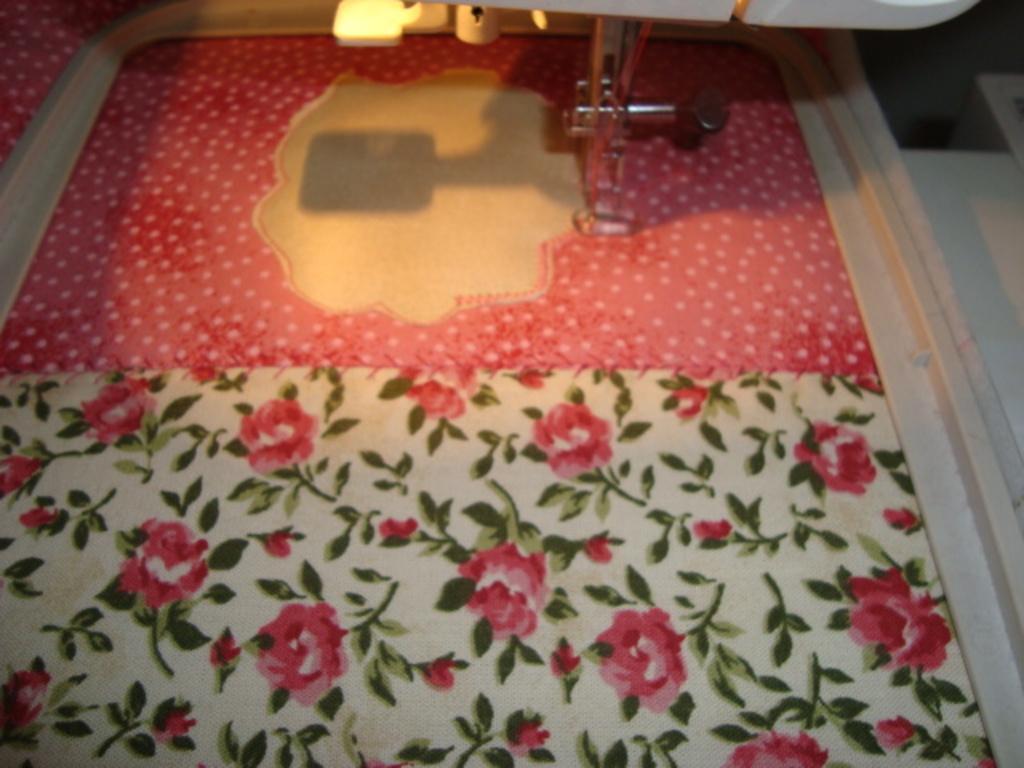Describe this image in one or two sentences. In this picture we can see a cloth and stitching machine. 